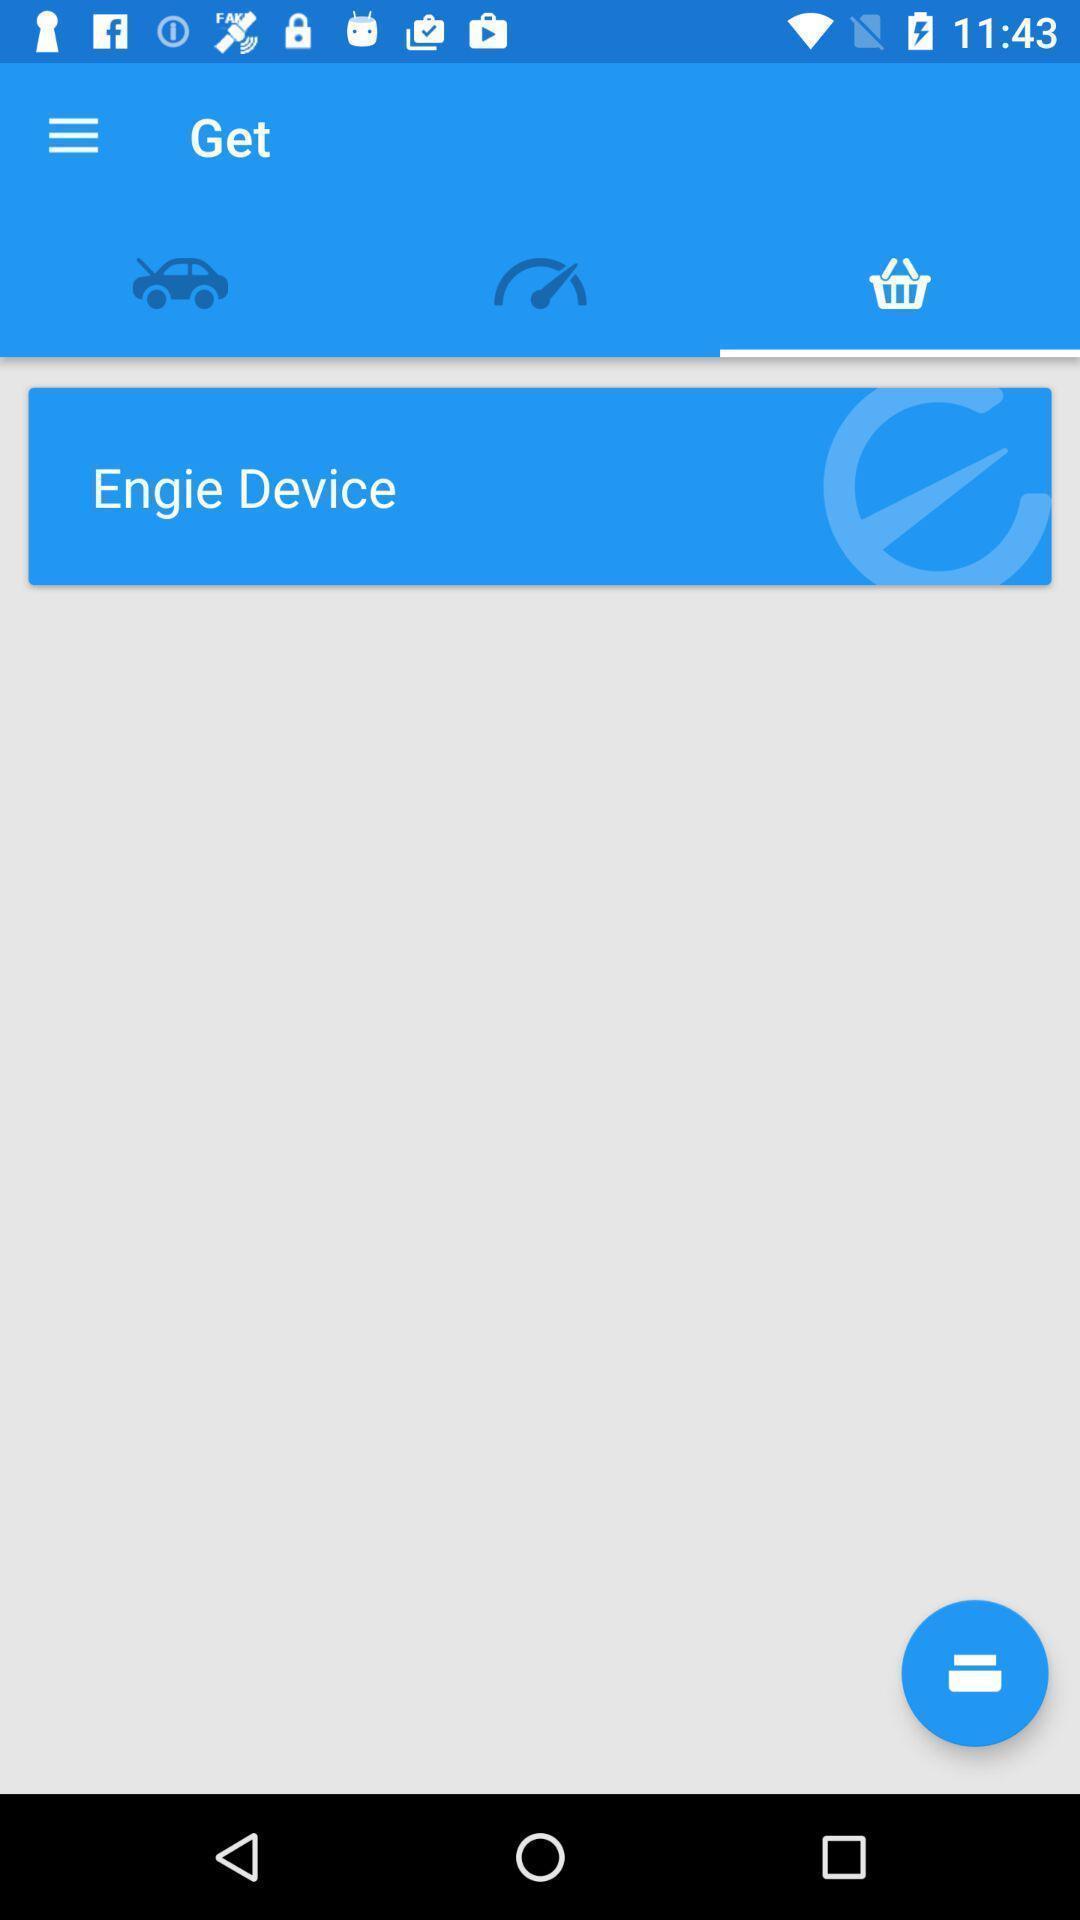Provide a detailed account of this screenshot. Page displaying the engie simplifies. 